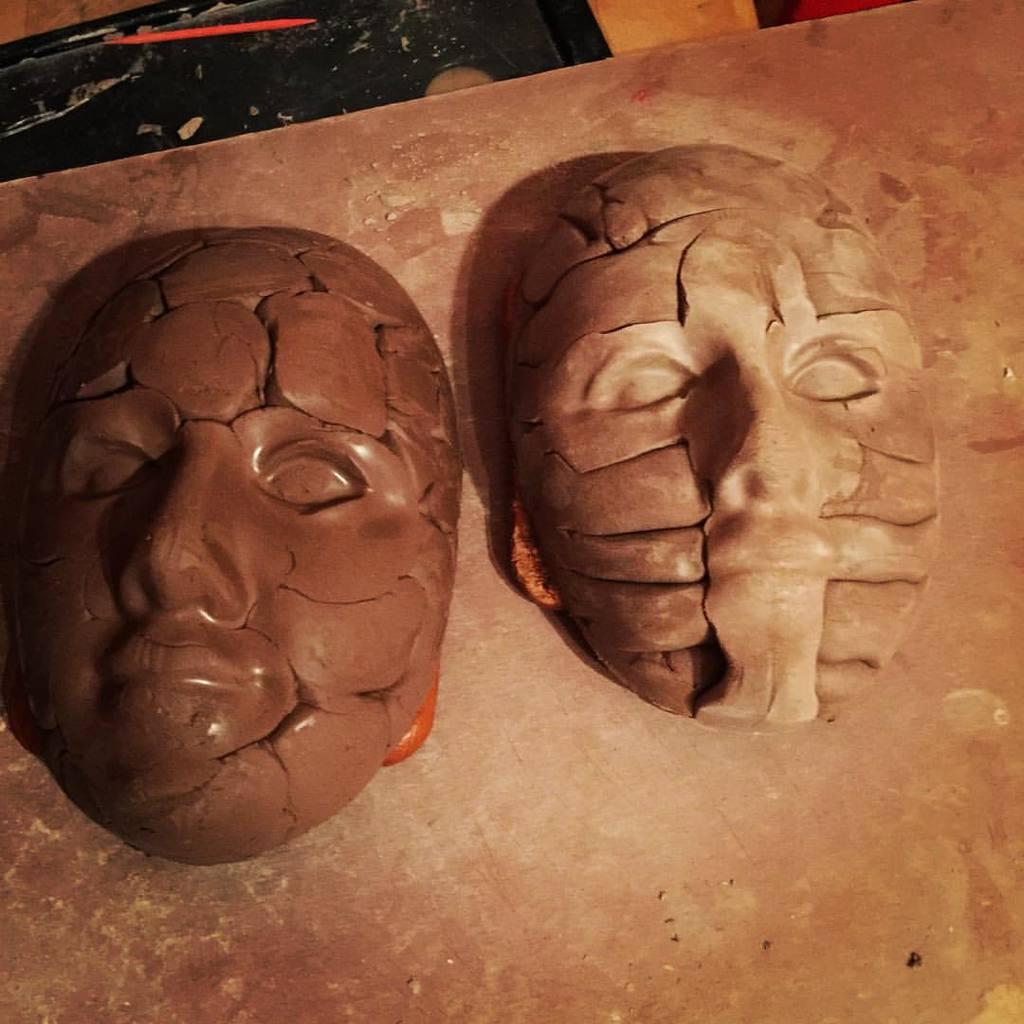How many masks are present in the image? There are two masks in the image. What are the colors of the masks? One mask is brown in color, and the other mask is cream in color. Where are the masks located in the image? The masks are on some surface. What organization is responsible for the wheel in the image? There is no wheel present in the image, so it is not possible to determine which organization might be responsible for it. 